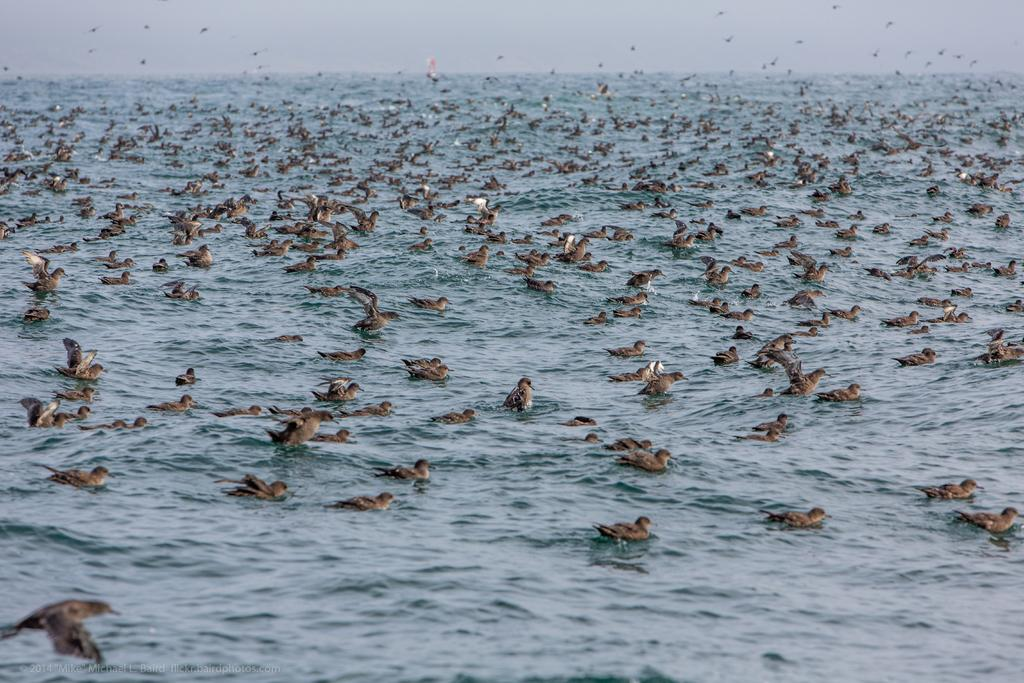What type of animals can be seen in the image? Birds can be seen in the image, both in the water and flying in the sky. What is the primary element in which the birds are situated? The birds are situated in water and flying in the sky. Can you describe the setting where the birds are located? The image appears to depict a sea, as there is water visible and the birds are interacting with it. What type of yard can be seen in the image? There is no yard present in the image; it features birds in the water and flying in the sky, as well as a sea setting. 